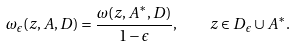Convert formula to latex. <formula><loc_0><loc_0><loc_500><loc_500>\omega _ { \epsilon } ( z , A , D ) = \frac { \omega ( z , A ^ { \ast } , D ) } { 1 - \epsilon } , \quad z \in D _ { \epsilon } \cup A ^ { \ast } .</formula> 